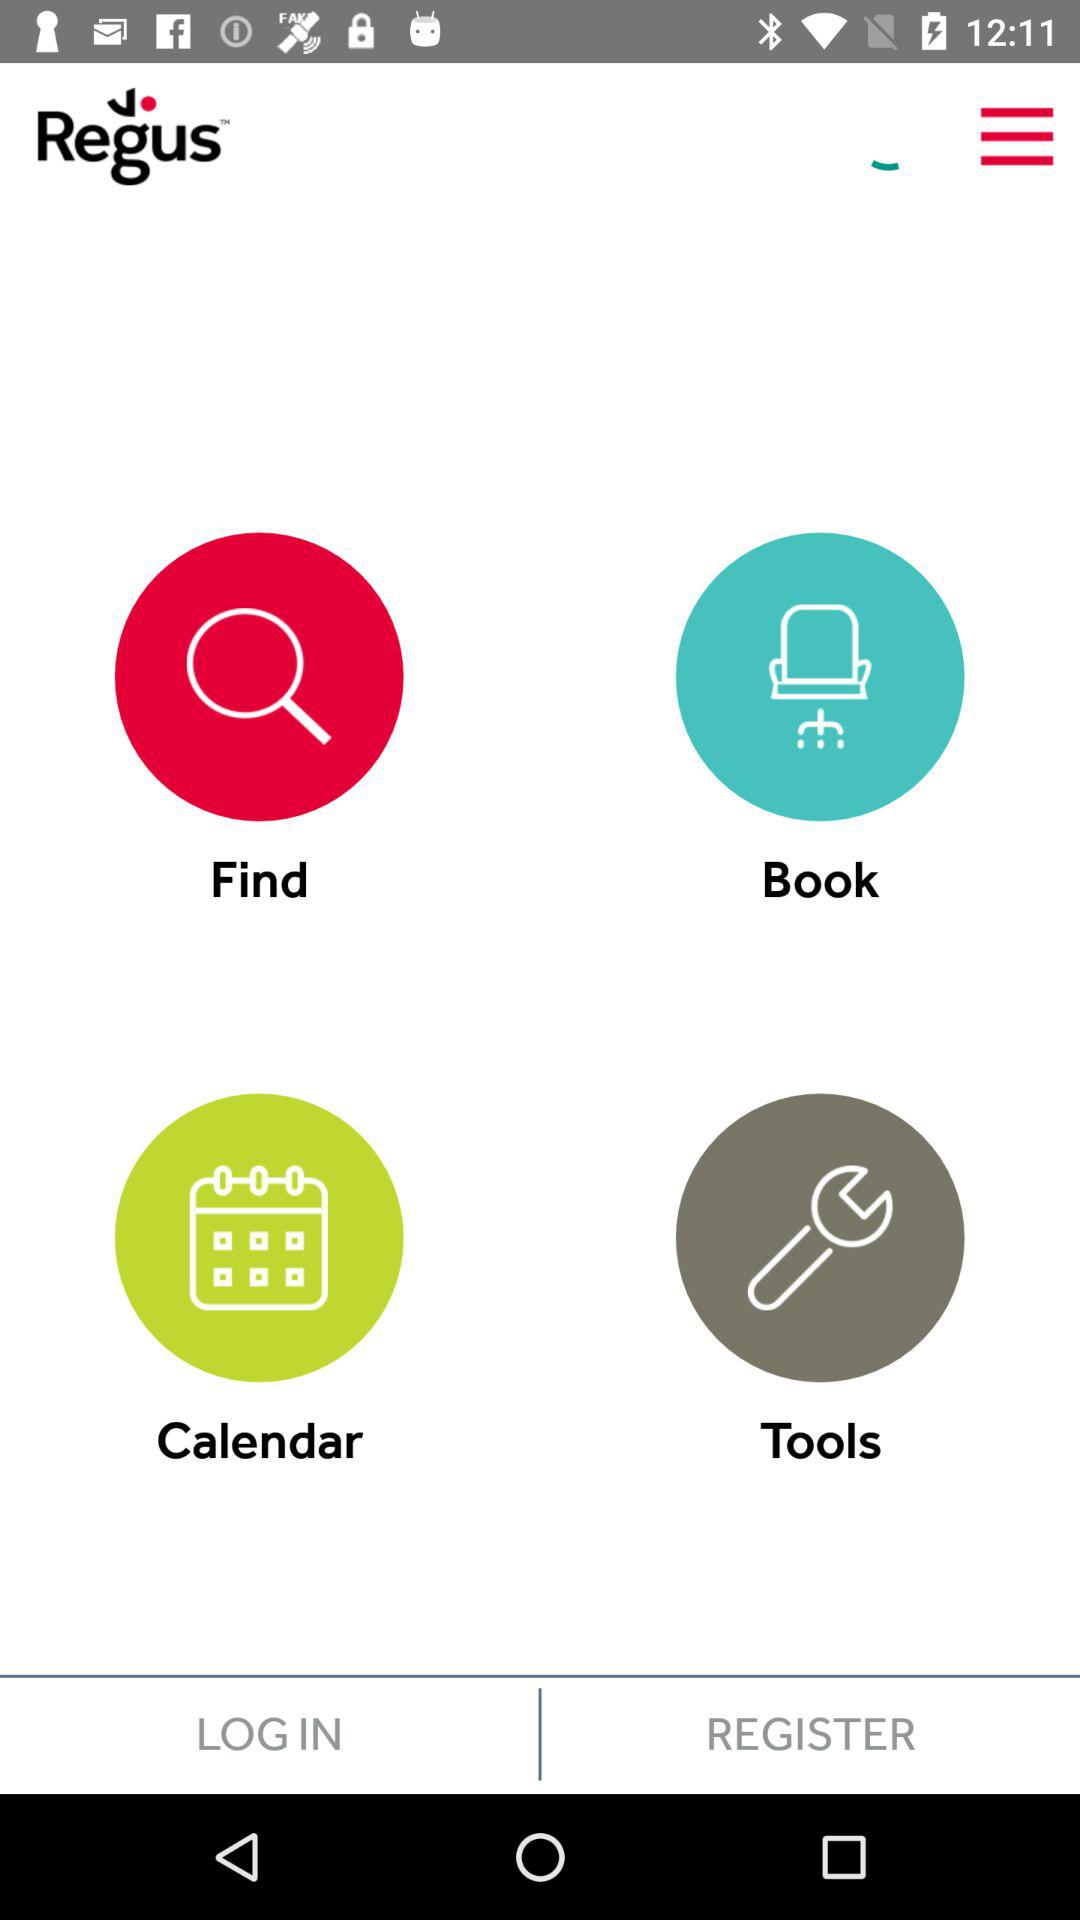What is the application Name? The application name is "Regus". 